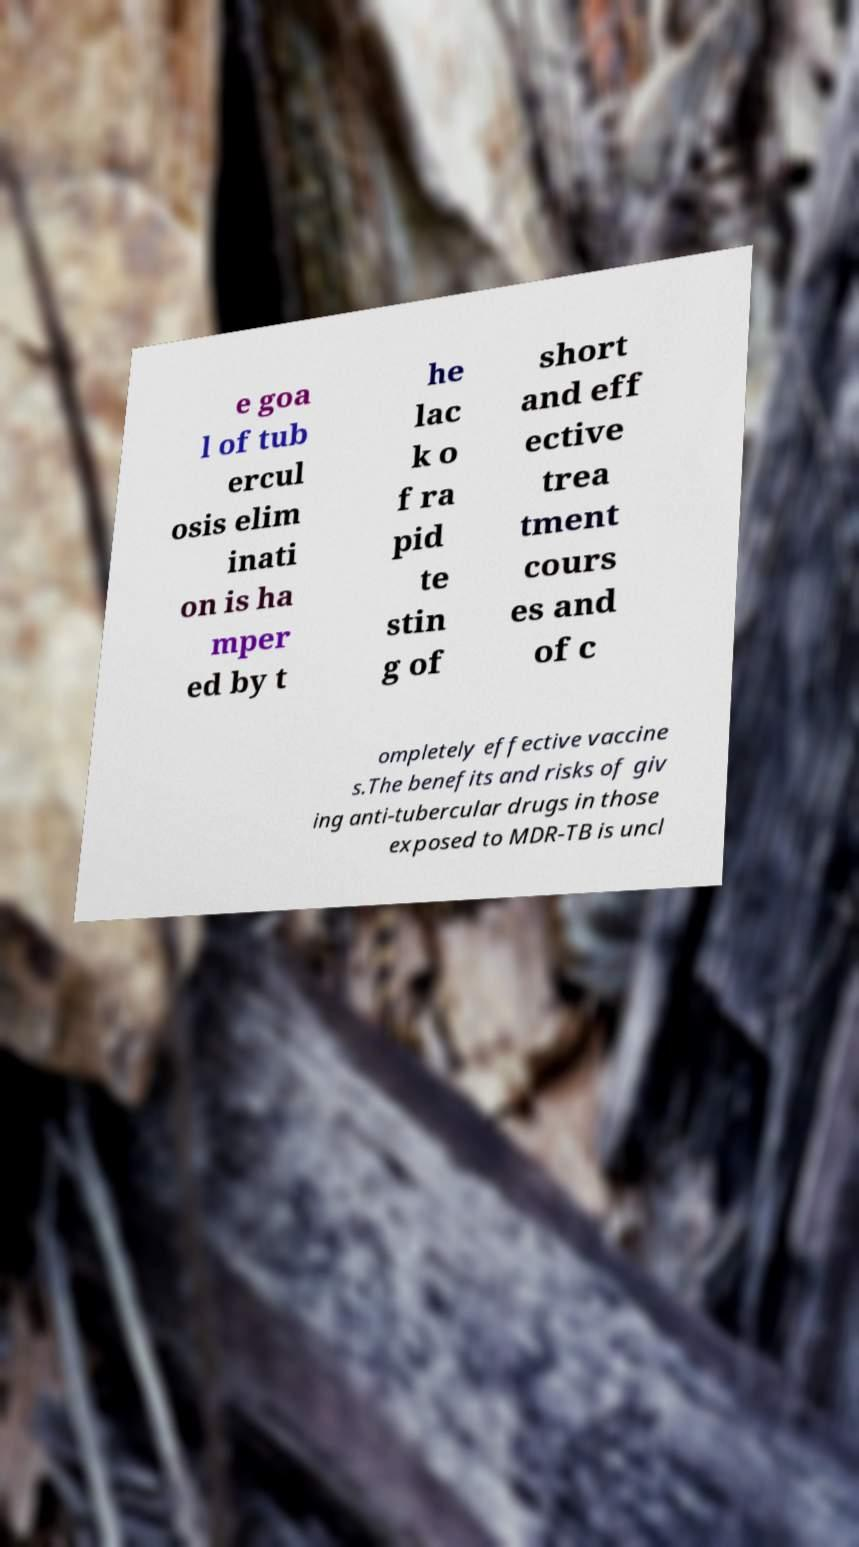What messages or text are displayed in this image? I need them in a readable, typed format. e goa l of tub ercul osis elim inati on is ha mper ed by t he lac k o f ra pid te stin g of short and eff ective trea tment cours es and of c ompletely effective vaccine s.The benefits and risks of giv ing anti-tubercular drugs in those exposed to MDR-TB is uncl 